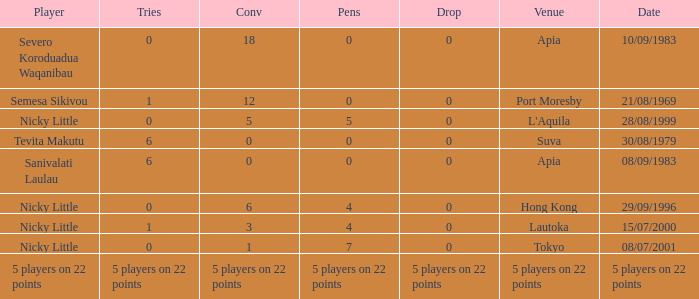How many conversions had no pens and no tries? 18.0. 